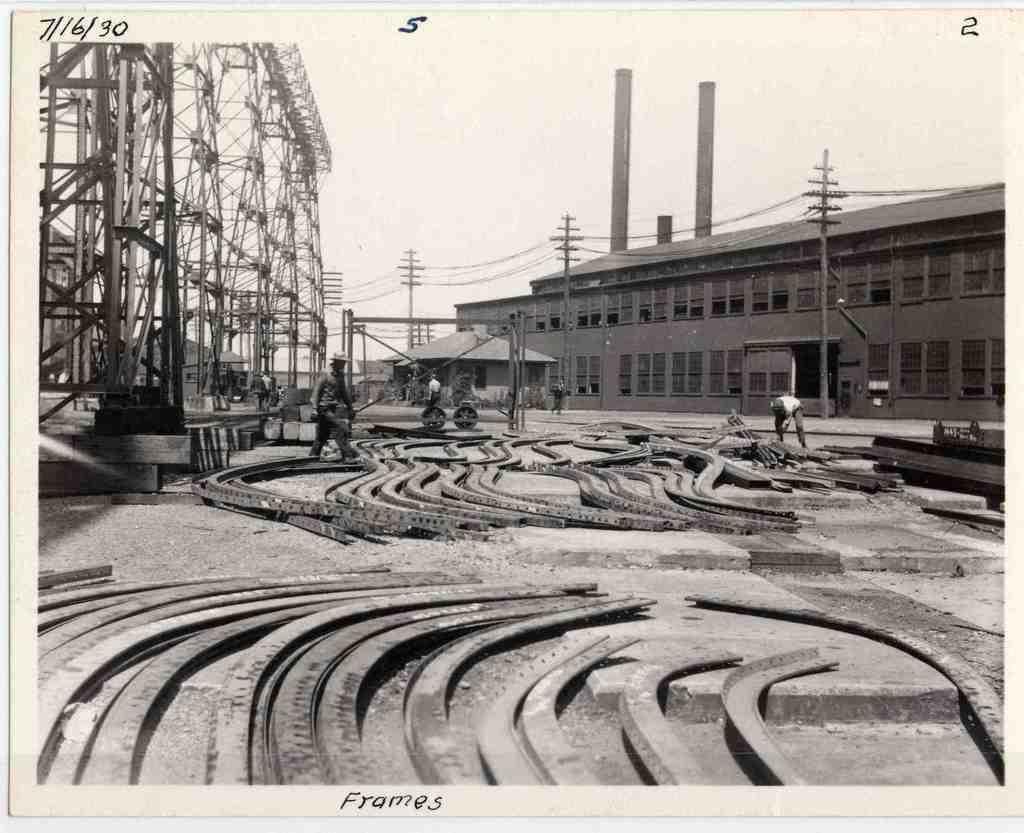Please provide a concise description of this image. In this picture we can see a poster, in the poster we can find few metal objects, buildings, poles and few people. 